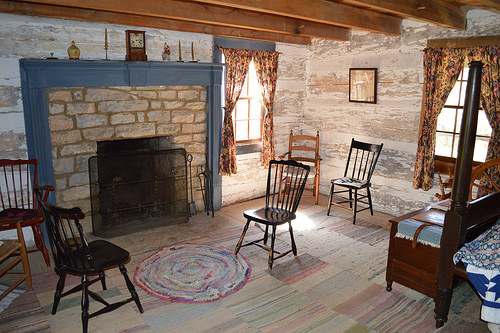<image>
Is the curtain on the wall? No. The curtain is not positioned on the wall. They may be near each other, but the curtain is not supported by or resting on top of the wall. Is there a fireplace under the window? No. The fireplace is not positioned under the window. The vertical relationship between these objects is different. 